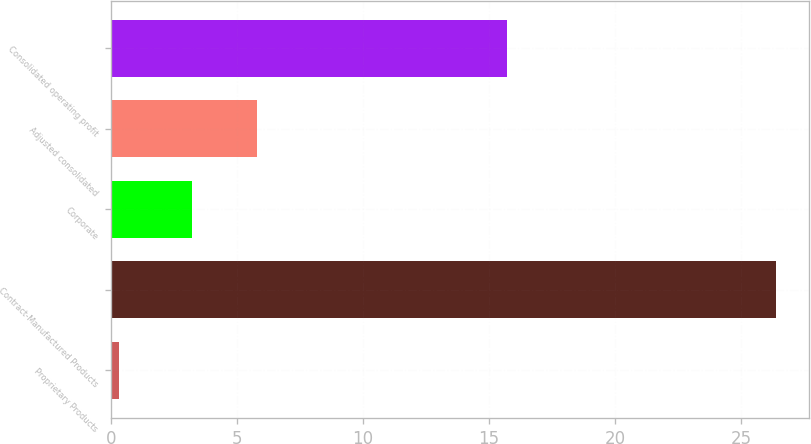Convert chart. <chart><loc_0><loc_0><loc_500><loc_500><bar_chart><fcel>Proprietary Products<fcel>Contract-Manufactured Products<fcel>Corporate<fcel>Adjusted consolidated<fcel>Consolidated operating profit<nl><fcel>0.3<fcel>26.4<fcel>3.2<fcel>5.81<fcel>15.7<nl></chart> 